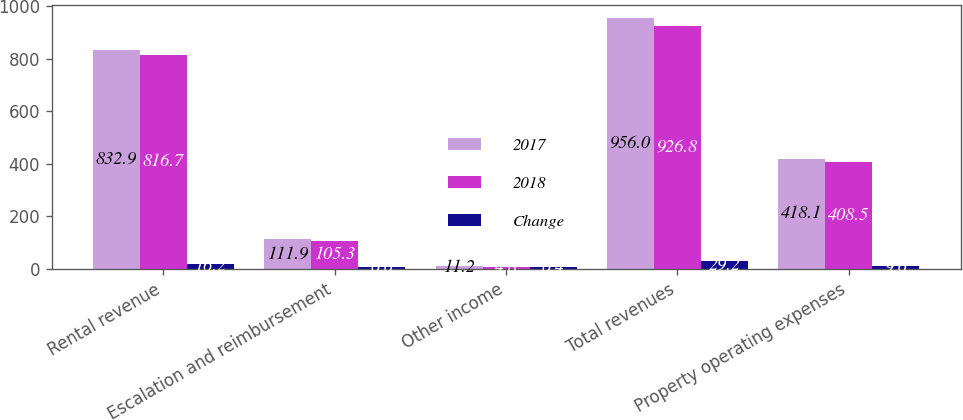Convert chart to OTSL. <chart><loc_0><loc_0><loc_500><loc_500><stacked_bar_chart><ecel><fcel>Rental revenue<fcel>Escalation and reimbursement<fcel>Other income<fcel>Total revenues<fcel>Property operating expenses<nl><fcel>2017<fcel>832.9<fcel>111.9<fcel>11.2<fcel>956<fcel>418.1<nl><fcel>2018<fcel>816.7<fcel>105.3<fcel>4.8<fcel>926.8<fcel>408.5<nl><fcel>Change<fcel>16.2<fcel>6.6<fcel>6.4<fcel>29.2<fcel>9.6<nl></chart> 